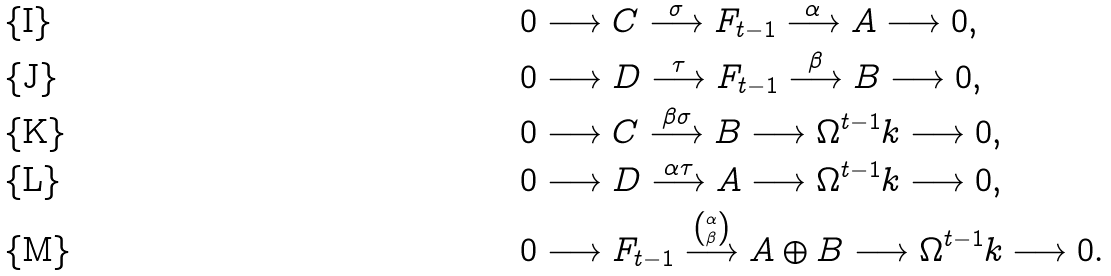<formula> <loc_0><loc_0><loc_500><loc_500>& 0 \longrightarrow C \overset { \sigma } { \longrightarrow } F _ { t - 1 } \overset { \alpha } { \longrightarrow } A \longrightarrow 0 , \\ & 0 \longrightarrow D \overset { \tau } { \longrightarrow } F _ { t - 1 } \overset { \beta } { \longrightarrow } B \longrightarrow 0 , \\ & 0 \longrightarrow C \overset { \beta \sigma } { \longrightarrow } B \longrightarrow \Omega ^ { t - 1 } k \longrightarrow 0 , \\ & 0 \longrightarrow D \overset { \alpha \tau } { \longrightarrow } A \longrightarrow \Omega ^ { t - 1 } k \longrightarrow 0 , \\ & 0 \longrightarrow F _ { t - 1 } \overset { \binom { \alpha } { \beta } } { \longrightarrow } A \oplus B \longrightarrow \Omega ^ { t - 1 } k \longrightarrow 0 .</formula> 